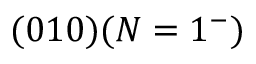Convert formula to latex. <formula><loc_0><loc_0><loc_500><loc_500>( 0 1 0 ) ( N = 1 ^ { - } )</formula> 